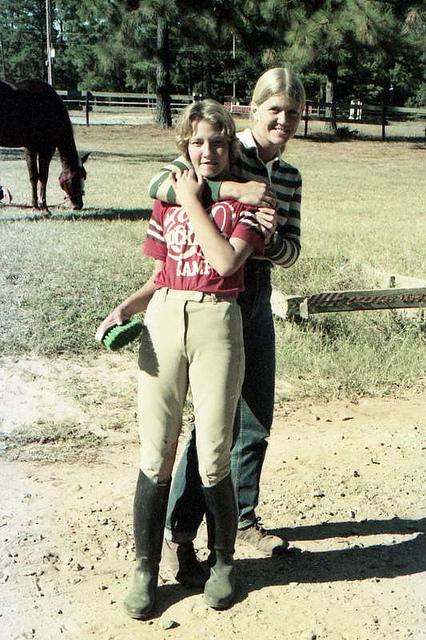What is the girl doing?
Keep it brief. Standing. Is this a foreign country?
Keep it brief. No. What is the horse's name in the background?
Quick response, please. Brownie. Which girl is wearing riding boots?
Short answer required. Front. 